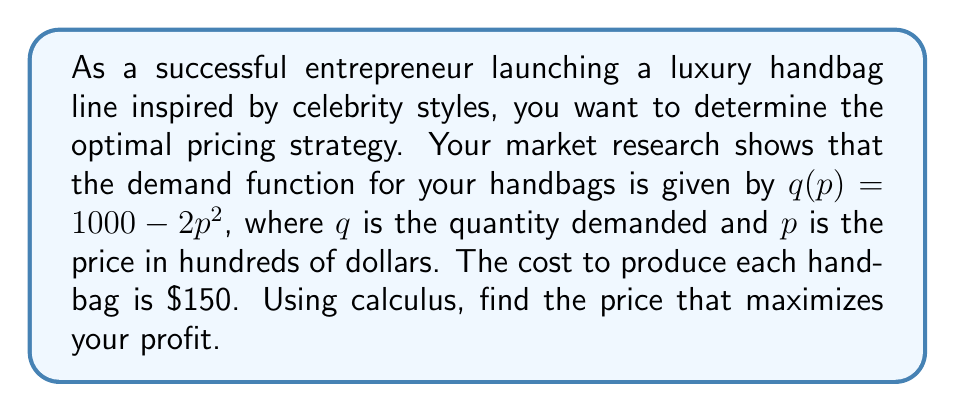Show me your answer to this math problem. Let's approach this step-by-step:

1) First, we need to formulate the profit function. Profit is revenue minus cost.
   
   Profit = Revenue - Cost
   $\Pi(p) = pq(p) - 150q(p)$

2) Substitute the demand function:
   $\Pi(p) = p(1000 - 2p^2) - 150(1000 - 2p^2)$

3) Expand the equation:
   $\Pi(p) = 1000p - 2p^3 - 150000 + 300p^2$

4) To find the maximum profit, we need to find where the derivative of the profit function equals zero:

   $\frac{d\Pi}{dp} = 1000 - 6p^2 + 600p$

5) Set this equal to zero and solve:
   $1000 - 6p^2 + 600p = 0$
   $6p^2 - 600p - 1000 = 0$

6) This is a quadratic equation. We can solve it using the quadratic formula:
   $p = \frac{-b \pm \sqrt{b^2 - 4ac}}{2a}$

   Where $a=6$, $b=-600$, and $c=-1000$

7) Solving this:
   $p = \frac{600 \pm \sqrt{360000 + 24000}}{12} = \frac{600 \pm 600\sqrt{1.0667}}{12}$

8) This gives us two solutions:
   $p \approx 101.35$ or $p \approx -1.35$

9) Since price can't be negative, we take the positive solution.

10) To confirm this is a maximum, we can check the second derivative:
    $\frac{d^2\Pi}{dp^2} = -12p + 600$
    At $p = 101.35$, this is negative, confirming a maximum.
Answer: $\$10,135$ per handbag 